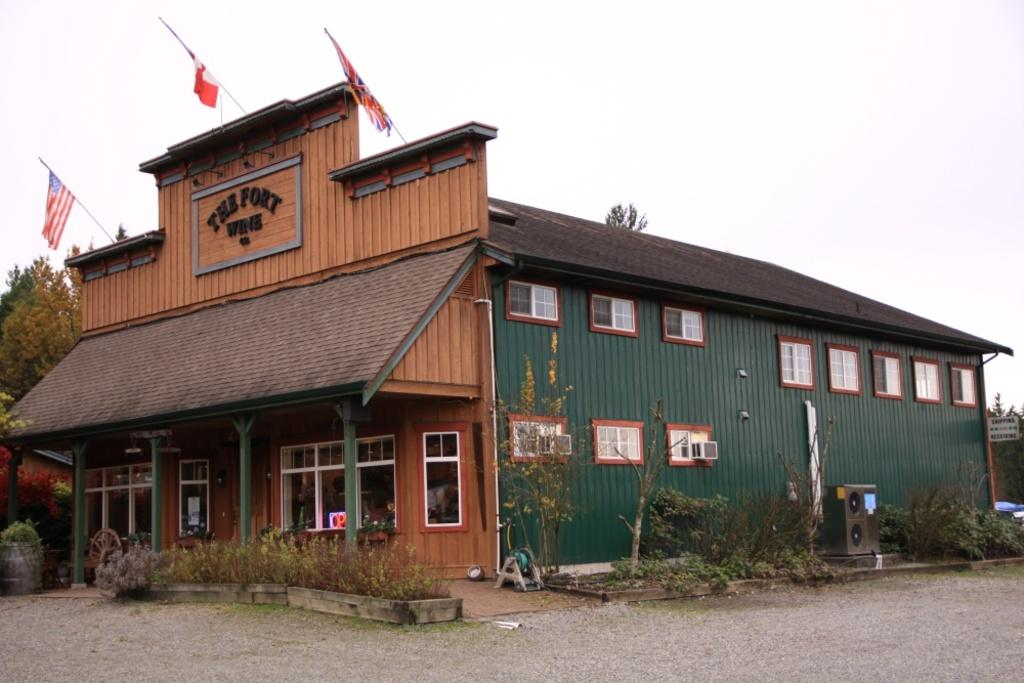What type of structure is visible in the image? There is a house in the image. What decorative elements can be seen in the image? There are flags in the image. What type of natural elements are present in the image? There are trees and plants in the image. What device is present in the image for producing sound? There is a sound box in the image. What is visible at the top of the image? The sky is visible at the top of the image. How many umbrellas are being used to increase profit in the image? There are no umbrellas or references to profit in the image. What level of difficulty is the house situated on in the image? The image does not provide information about the level or elevation of the house. 